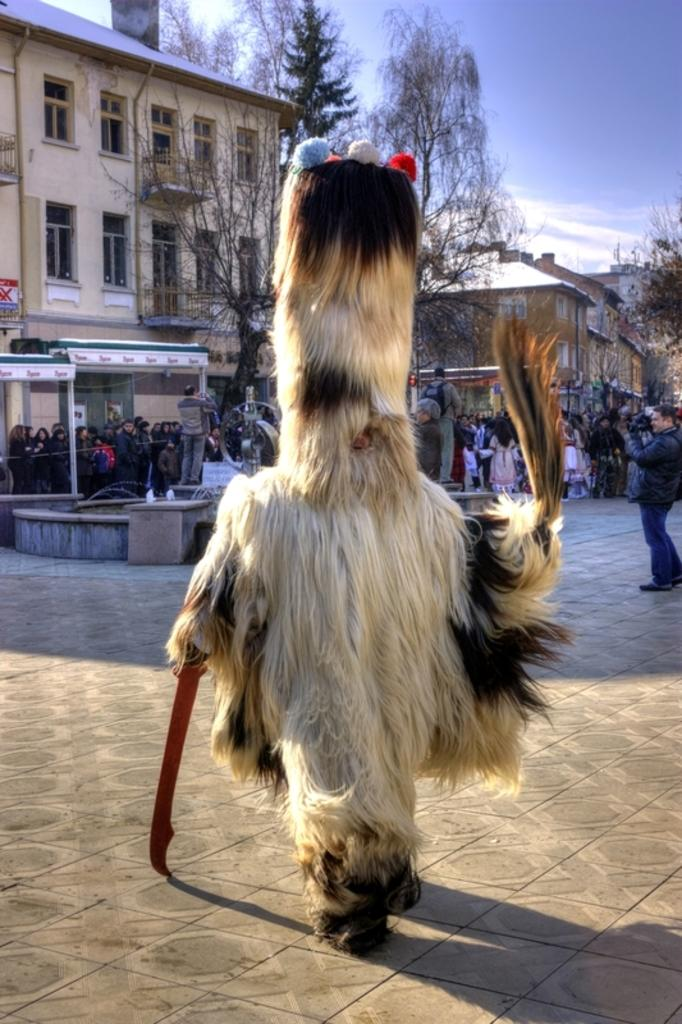What is the main subject in the center of the image? There is a person with costumes in the center of the image. What can be seen in the background of the image? There are persons, trees, buildings, and the sky visible in the background of the image. What is the condition of the sky in the image? The sky is visible in the background of the image, and there are clouds present. What type of toe can be seen on the person's foot in the image? There is no visible toe on the person's foot in the image. What is the person using to lick the ice cream in the image? There is no ice cream or tongue visible in the image. What is the person using to carry water in the image? There is no pail or water-carrying activity depicted in the image. 